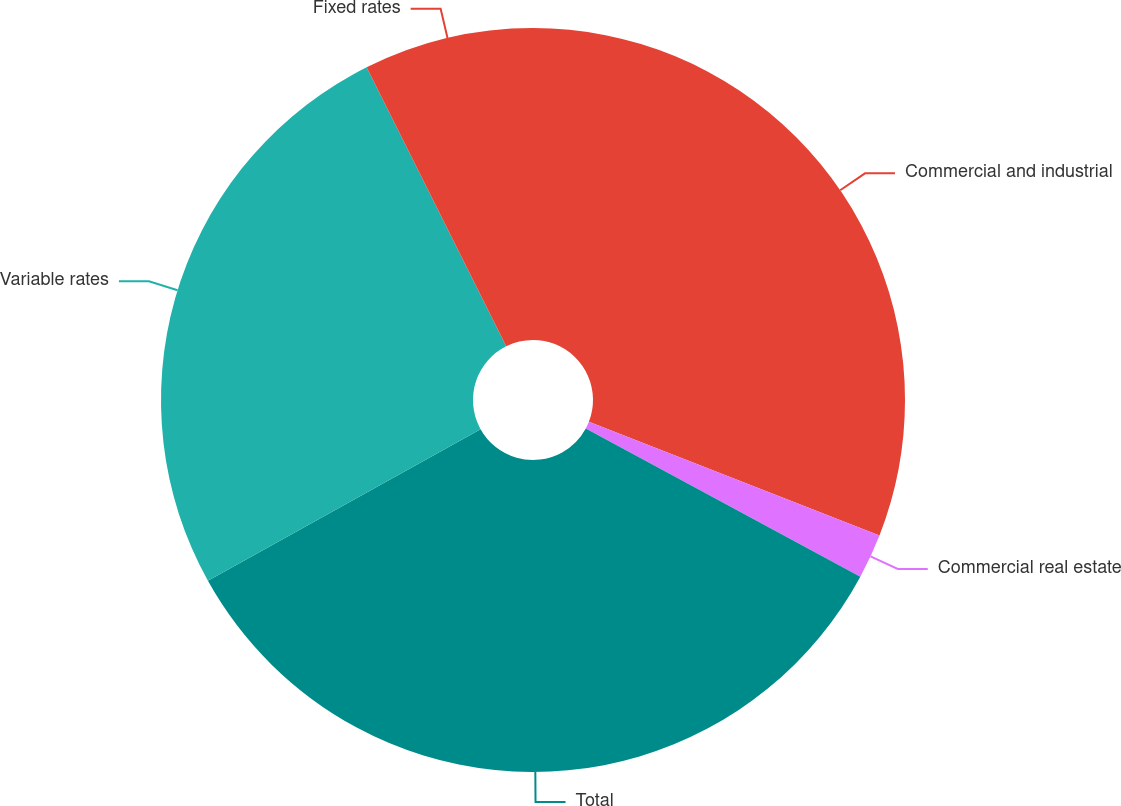Convert chart to OTSL. <chart><loc_0><loc_0><loc_500><loc_500><pie_chart><fcel>Commercial and industrial<fcel>Commercial real estate<fcel>Total<fcel>Variable rates<fcel>Fixed rates<nl><fcel>30.93%<fcel>1.95%<fcel>34.04%<fcel>25.7%<fcel>7.38%<nl></chart> 